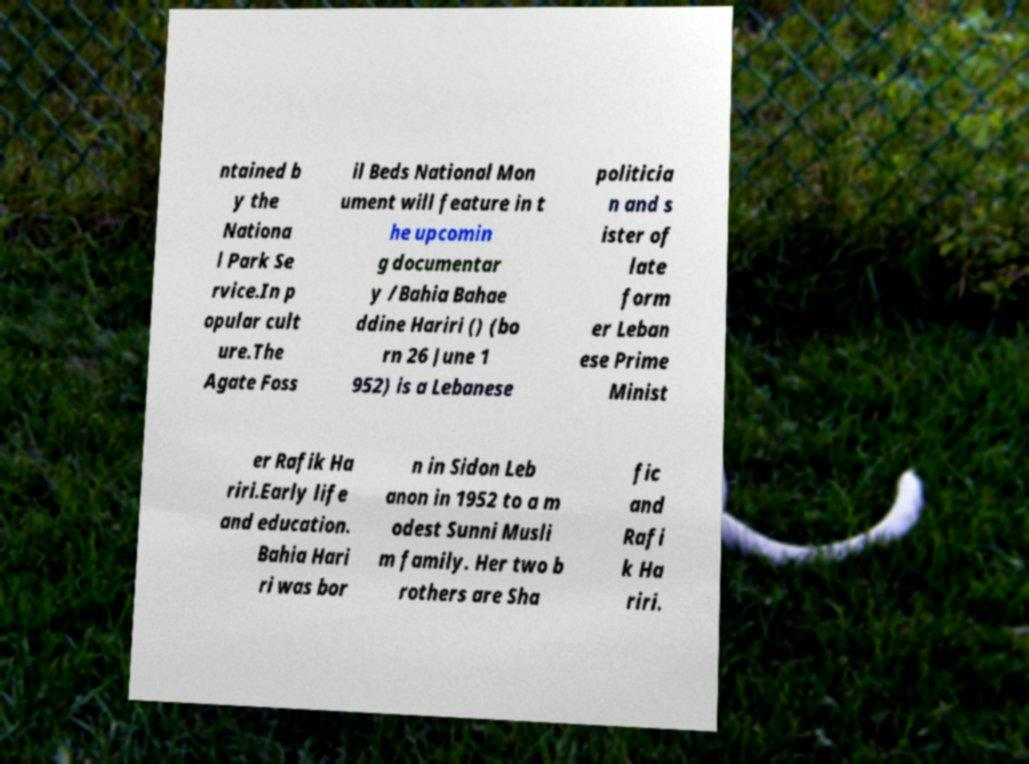I need the written content from this picture converted into text. Can you do that? ntained b y the Nationa l Park Se rvice.In p opular cult ure.The Agate Foss il Beds National Mon ument will feature in t he upcomin g documentar y /Bahia Bahae ddine Hariri () (bo rn 26 June 1 952) is a Lebanese politicia n and s ister of late form er Leban ese Prime Minist er Rafik Ha riri.Early life and education. Bahia Hari ri was bor n in Sidon Leb anon in 1952 to a m odest Sunni Musli m family. Her two b rothers are Sha fic and Rafi k Ha riri. 